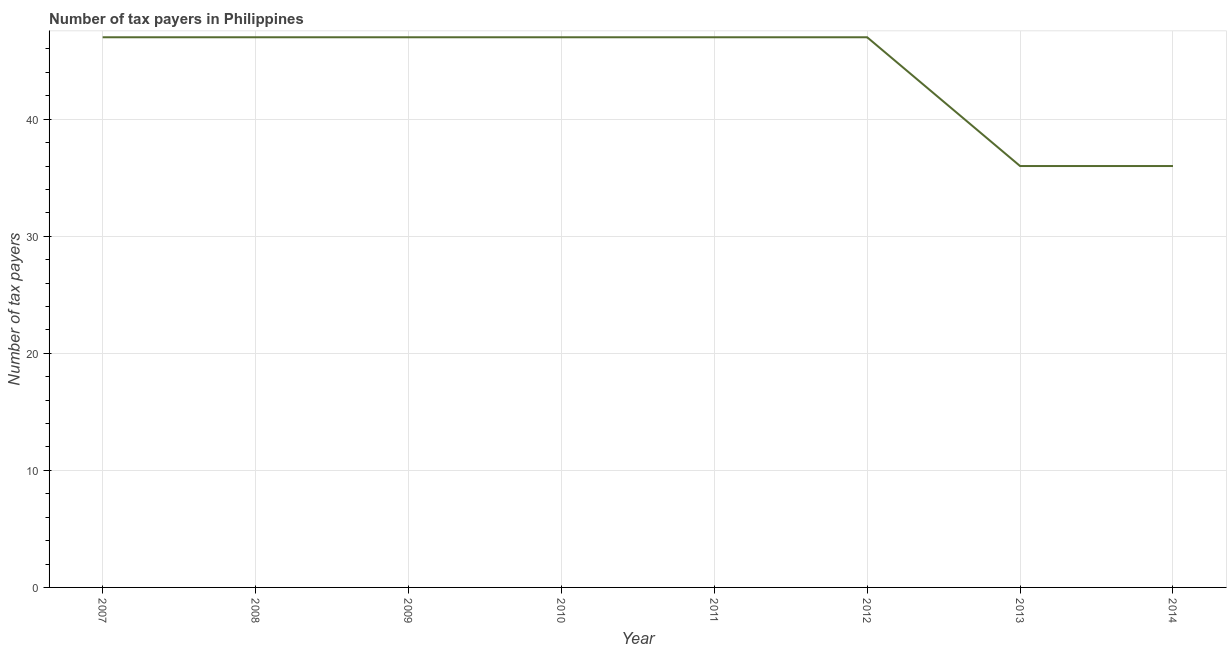What is the number of tax payers in 2011?
Offer a terse response. 47. Across all years, what is the maximum number of tax payers?
Offer a very short reply. 47. Across all years, what is the minimum number of tax payers?
Provide a short and direct response. 36. In which year was the number of tax payers maximum?
Your response must be concise. 2007. In which year was the number of tax payers minimum?
Your response must be concise. 2013. What is the sum of the number of tax payers?
Offer a very short reply. 354. What is the difference between the number of tax payers in 2007 and 2013?
Ensure brevity in your answer.  11. What is the average number of tax payers per year?
Keep it short and to the point. 44.25. What is the median number of tax payers?
Your response must be concise. 47. In how many years, is the number of tax payers greater than 4 ?
Ensure brevity in your answer.  8. Is the number of tax payers in 2008 less than that in 2014?
Provide a short and direct response. No. What is the difference between the highest and the second highest number of tax payers?
Offer a very short reply. 0. Is the sum of the number of tax payers in 2010 and 2013 greater than the maximum number of tax payers across all years?
Give a very brief answer. Yes. What is the difference between the highest and the lowest number of tax payers?
Your answer should be compact. 11. In how many years, is the number of tax payers greater than the average number of tax payers taken over all years?
Keep it short and to the point. 6. Does the number of tax payers monotonically increase over the years?
Offer a very short reply. No. How many lines are there?
Give a very brief answer. 1. How many years are there in the graph?
Provide a short and direct response. 8. What is the difference between two consecutive major ticks on the Y-axis?
Your answer should be compact. 10. Are the values on the major ticks of Y-axis written in scientific E-notation?
Your answer should be very brief. No. Does the graph contain grids?
Your answer should be very brief. Yes. What is the title of the graph?
Give a very brief answer. Number of tax payers in Philippines. What is the label or title of the Y-axis?
Ensure brevity in your answer.  Number of tax payers. What is the Number of tax payers in 2008?
Provide a short and direct response. 47. What is the Number of tax payers of 2009?
Give a very brief answer. 47. What is the Number of tax payers of 2010?
Ensure brevity in your answer.  47. What is the Number of tax payers of 2011?
Your answer should be compact. 47. What is the Number of tax payers of 2012?
Make the answer very short. 47. What is the Number of tax payers of 2014?
Make the answer very short. 36. What is the difference between the Number of tax payers in 2007 and 2010?
Your answer should be compact. 0. What is the difference between the Number of tax payers in 2007 and 2011?
Offer a very short reply. 0. What is the difference between the Number of tax payers in 2007 and 2012?
Keep it short and to the point. 0. What is the difference between the Number of tax payers in 2007 and 2013?
Give a very brief answer. 11. What is the difference between the Number of tax payers in 2008 and 2010?
Offer a terse response. 0. What is the difference between the Number of tax payers in 2008 and 2012?
Offer a very short reply. 0. What is the difference between the Number of tax payers in 2008 and 2014?
Keep it short and to the point. 11. What is the difference between the Number of tax payers in 2009 and 2012?
Offer a very short reply. 0. What is the difference between the Number of tax payers in 2010 and 2012?
Your answer should be compact. 0. What is the difference between the Number of tax payers in 2010 and 2013?
Offer a terse response. 11. What is the difference between the Number of tax payers in 2010 and 2014?
Ensure brevity in your answer.  11. What is the difference between the Number of tax payers in 2011 and 2013?
Keep it short and to the point. 11. What is the difference between the Number of tax payers in 2011 and 2014?
Offer a very short reply. 11. What is the difference between the Number of tax payers in 2012 and 2014?
Make the answer very short. 11. What is the difference between the Number of tax payers in 2013 and 2014?
Ensure brevity in your answer.  0. What is the ratio of the Number of tax payers in 2007 to that in 2010?
Keep it short and to the point. 1. What is the ratio of the Number of tax payers in 2007 to that in 2012?
Make the answer very short. 1. What is the ratio of the Number of tax payers in 2007 to that in 2013?
Provide a short and direct response. 1.31. What is the ratio of the Number of tax payers in 2007 to that in 2014?
Your answer should be compact. 1.31. What is the ratio of the Number of tax payers in 2008 to that in 2013?
Keep it short and to the point. 1.31. What is the ratio of the Number of tax payers in 2008 to that in 2014?
Ensure brevity in your answer.  1.31. What is the ratio of the Number of tax payers in 2009 to that in 2012?
Your answer should be compact. 1. What is the ratio of the Number of tax payers in 2009 to that in 2013?
Offer a terse response. 1.31. What is the ratio of the Number of tax payers in 2009 to that in 2014?
Your response must be concise. 1.31. What is the ratio of the Number of tax payers in 2010 to that in 2011?
Provide a short and direct response. 1. What is the ratio of the Number of tax payers in 2010 to that in 2012?
Make the answer very short. 1. What is the ratio of the Number of tax payers in 2010 to that in 2013?
Give a very brief answer. 1.31. What is the ratio of the Number of tax payers in 2010 to that in 2014?
Keep it short and to the point. 1.31. What is the ratio of the Number of tax payers in 2011 to that in 2013?
Provide a succinct answer. 1.31. What is the ratio of the Number of tax payers in 2011 to that in 2014?
Offer a very short reply. 1.31. What is the ratio of the Number of tax payers in 2012 to that in 2013?
Your response must be concise. 1.31. What is the ratio of the Number of tax payers in 2012 to that in 2014?
Offer a very short reply. 1.31. What is the ratio of the Number of tax payers in 2013 to that in 2014?
Your response must be concise. 1. 